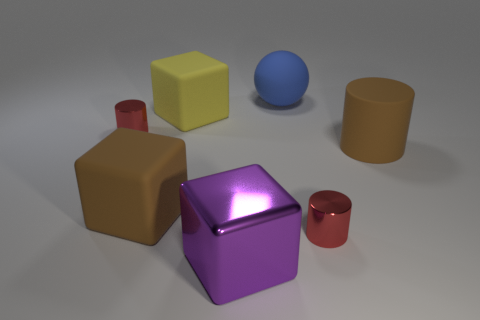Is there a thing that has the same color as the big cylinder?
Your answer should be very brief. Yes. Does the small object on the right side of the big purple thing have the same color as the metallic thing that is left of the yellow matte cube?
Give a very brief answer. Yes. Is there a red cylinder?
Offer a very short reply. Yes. There is a object that is both right of the big purple block and behind the big matte cylinder; what is its size?
Provide a succinct answer. Large. Are there more large things behind the big purple cube than matte things that are behind the matte sphere?
Your answer should be compact. Yes. What is the size of the matte object that is the same color as the big cylinder?
Provide a succinct answer. Large. What color is the big metallic block?
Your response must be concise. Purple. There is a thing that is both in front of the brown block and to the right of the blue object; what is its color?
Offer a very short reply. Red. What color is the big rubber object that is on the right side of the tiny thing on the right side of the red thing to the left of the large matte ball?
Provide a short and direct response. Brown. There is a cylinder that is the same size as the rubber sphere; what color is it?
Give a very brief answer. Brown. 